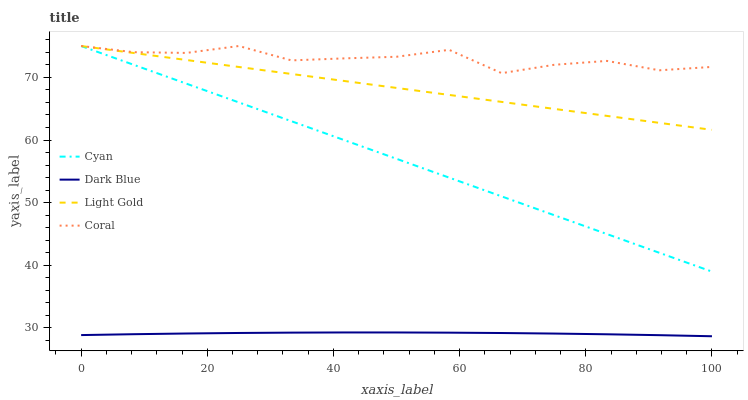Does Dark Blue have the minimum area under the curve?
Answer yes or no. Yes. Does Coral have the maximum area under the curve?
Answer yes or no. Yes. Does Light Gold have the minimum area under the curve?
Answer yes or no. No. Does Light Gold have the maximum area under the curve?
Answer yes or no. No. Is Light Gold the smoothest?
Answer yes or no. Yes. Is Coral the roughest?
Answer yes or no. Yes. Is Coral the smoothest?
Answer yes or no. No. Is Light Gold the roughest?
Answer yes or no. No. Does Dark Blue have the lowest value?
Answer yes or no. Yes. Does Light Gold have the lowest value?
Answer yes or no. No. Does Light Gold have the highest value?
Answer yes or no. Yes. Does Dark Blue have the highest value?
Answer yes or no. No. Is Dark Blue less than Coral?
Answer yes or no. Yes. Is Cyan greater than Dark Blue?
Answer yes or no. Yes. Does Coral intersect Light Gold?
Answer yes or no. Yes. Is Coral less than Light Gold?
Answer yes or no. No. Is Coral greater than Light Gold?
Answer yes or no. No. Does Dark Blue intersect Coral?
Answer yes or no. No. 